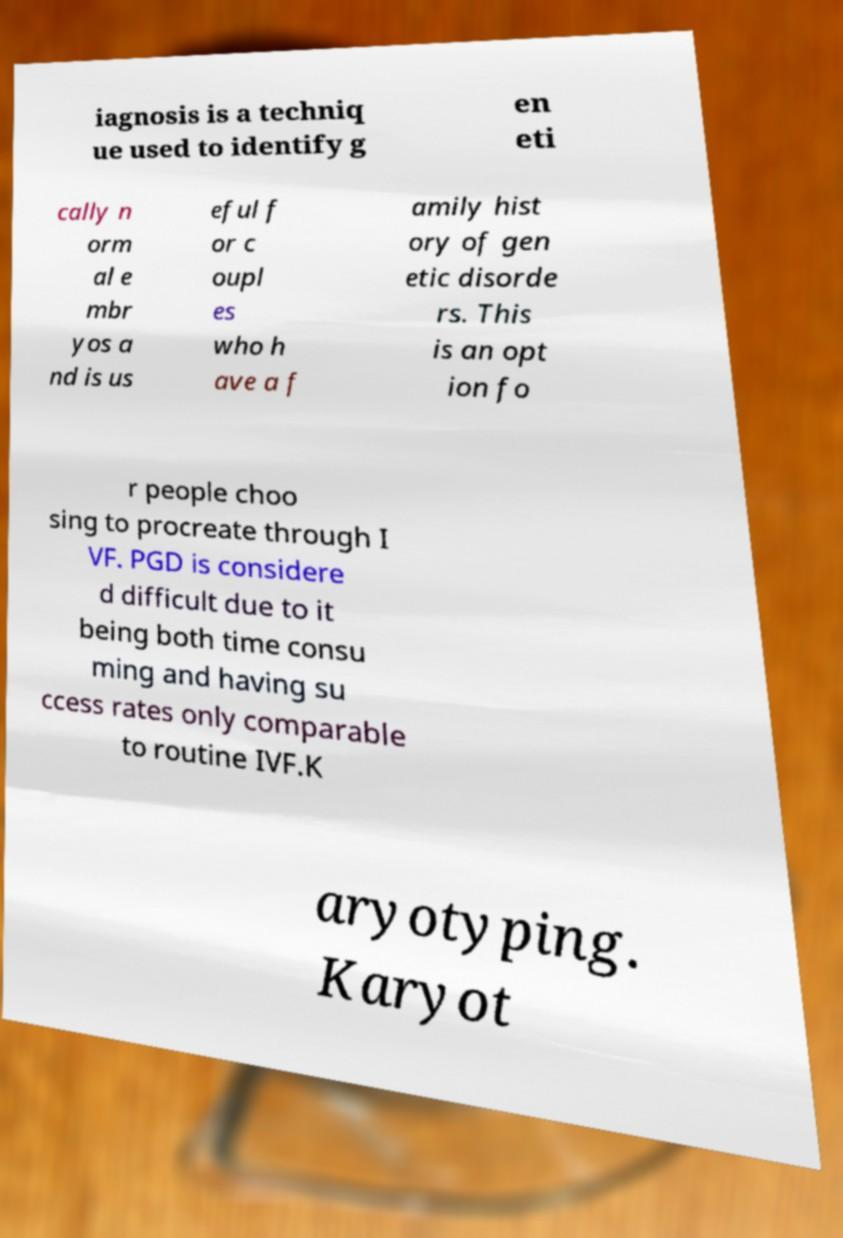What messages or text are displayed in this image? I need them in a readable, typed format. iagnosis is a techniq ue used to identify g en eti cally n orm al e mbr yos a nd is us eful f or c oupl es who h ave a f amily hist ory of gen etic disorde rs. This is an opt ion fo r people choo sing to procreate through I VF. PGD is considere d difficult due to it being both time consu ming and having su ccess rates only comparable to routine IVF.K aryotyping. Karyot 